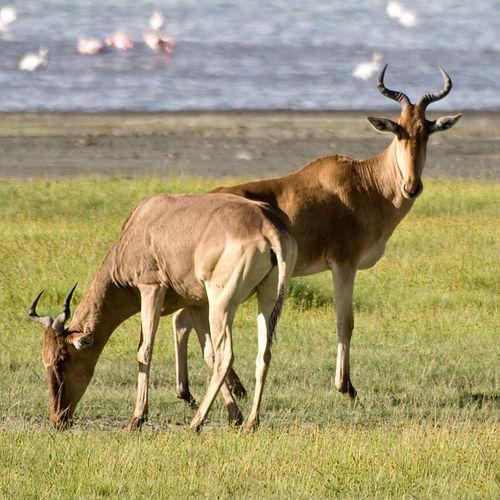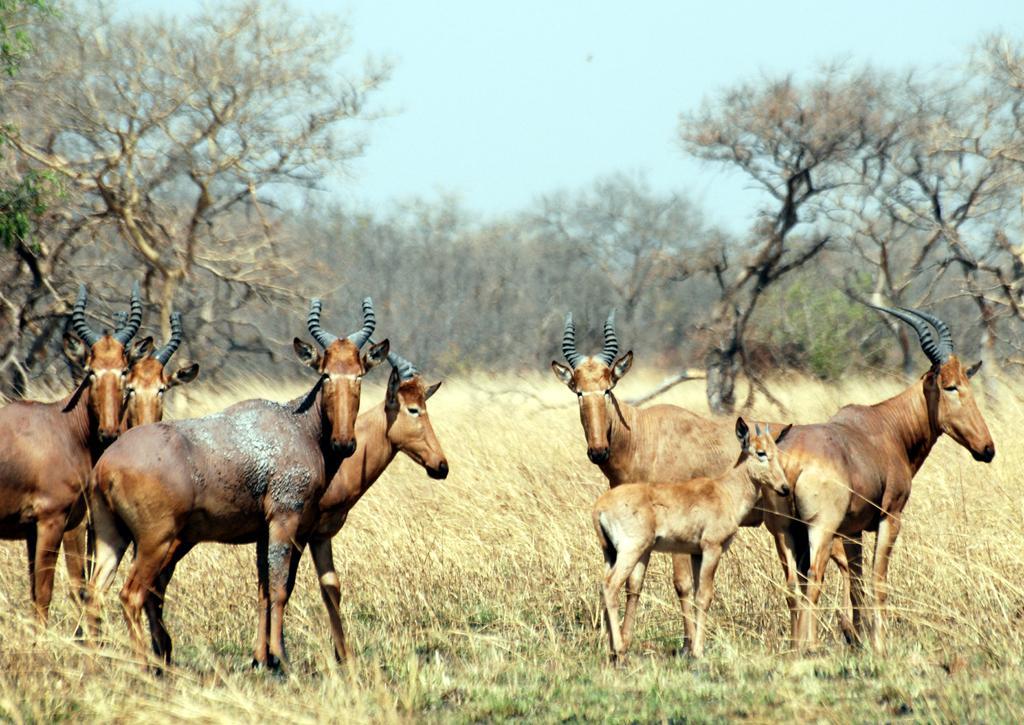The first image is the image on the left, the second image is the image on the right. Considering the images on both sides, is "One of the images has only one living creature." valid? Answer yes or no. No. The first image is the image on the left, the second image is the image on the right. For the images displayed, is the sentence "One image contains at least three times the number of hooved animals as the other image." factually correct? Answer yes or no. Yes. 